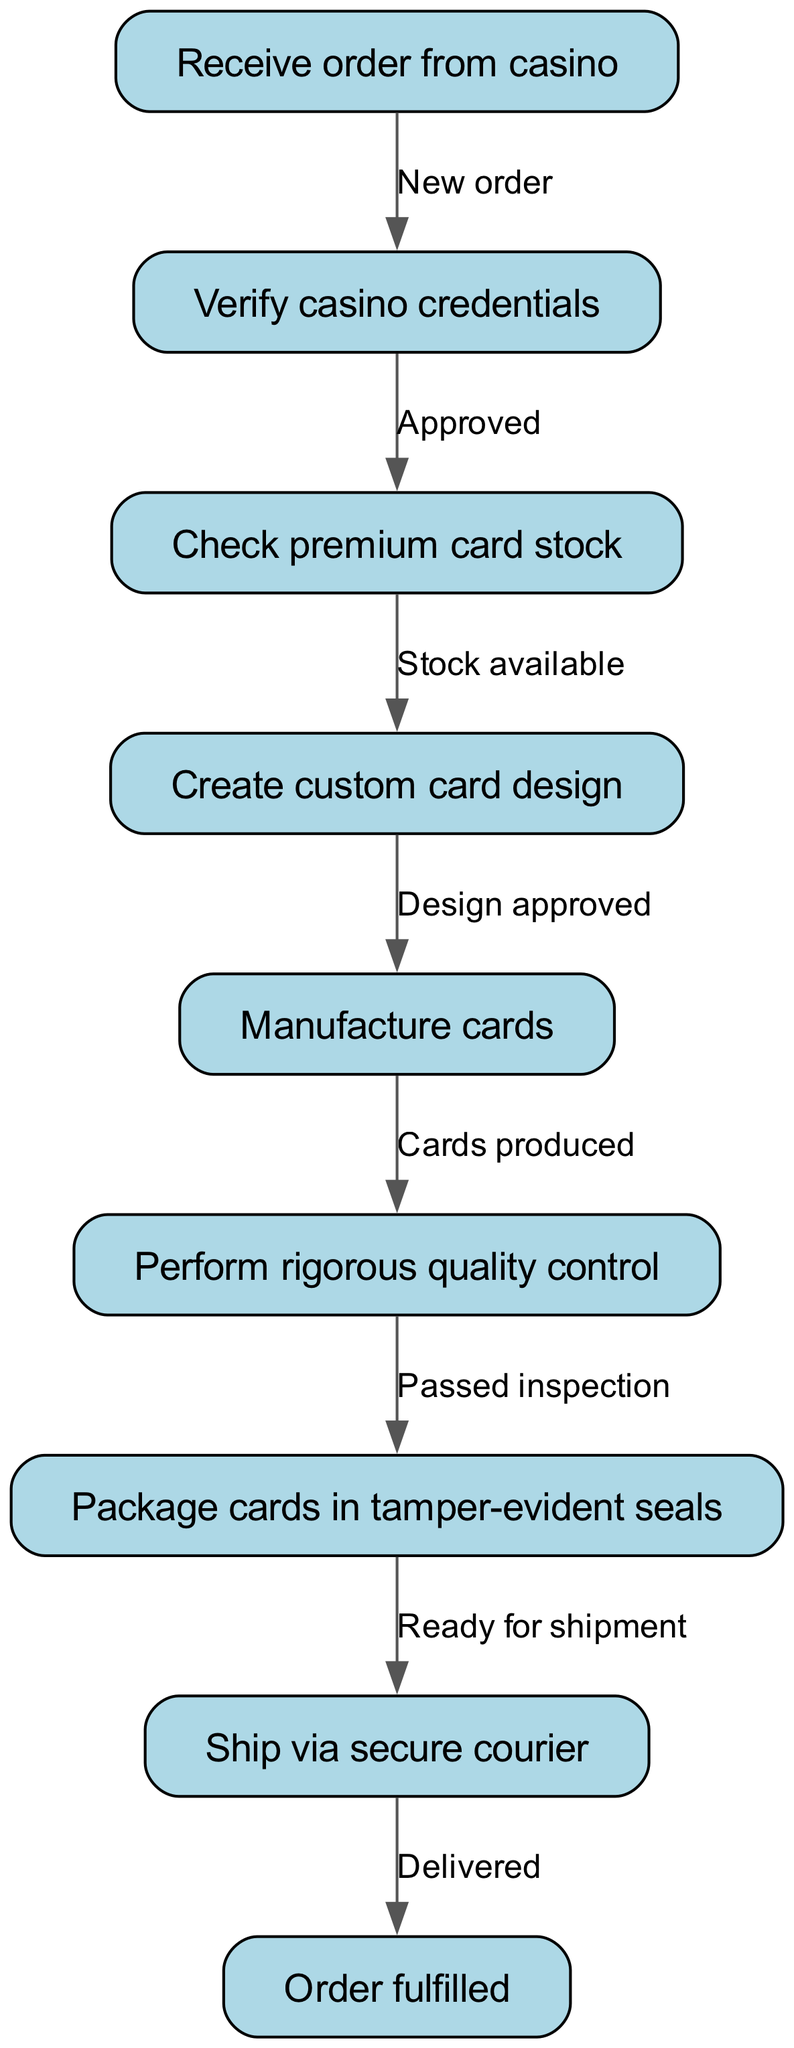What is the first step in the order fulfillment process? The diagram indicates that the first step is to "Receive order from casino" as it is the starting node of the flowchart.
Answer: Receive order from casino How many nodes are in the flowchart? By counting the nodes listed in the diagram, we find there are eight distinct nodes representing different steps in the order fulfillment process.
Answer: Eight What happens after the "Verify casino credentials" step? The diagram shows that after verifying the casino credentials, the flow proceeds to "Check premium card stock" if the credentials are approved.
Answer: Check premium card stock What is the final step depicted in the diagram? The diagram concludes with the step labeled as "Order fulfilled," which signifies the end of the entire fulfillment process.
Answer: Order fulfilled What must happen before the cards can be shipped? According to the flowchart, the cards must be "Packed in tamper-evident seals" before proceeds to "Ship via secure courier."
Answer: Packaged What edge connects the "Production" node to the "Quality check" node? The edge indicates that it connects the nodes as "Cards produced," showing that production must occur before quality control.
Answer: Cards produced What is required after "Create custom card design"? The next step after creating the custom card design is for the design to be evaluated to ensure it is "Design approved," before moving on to production.
Answer: Design approved How does the process progress if stock is unavailable? The flowchart does not directly represent stock unavailability; it implies that if stock is unavailable, no alternative route is shown from "Check premium card stock," suggesting the process cannot continue.
Answer: Not specified 